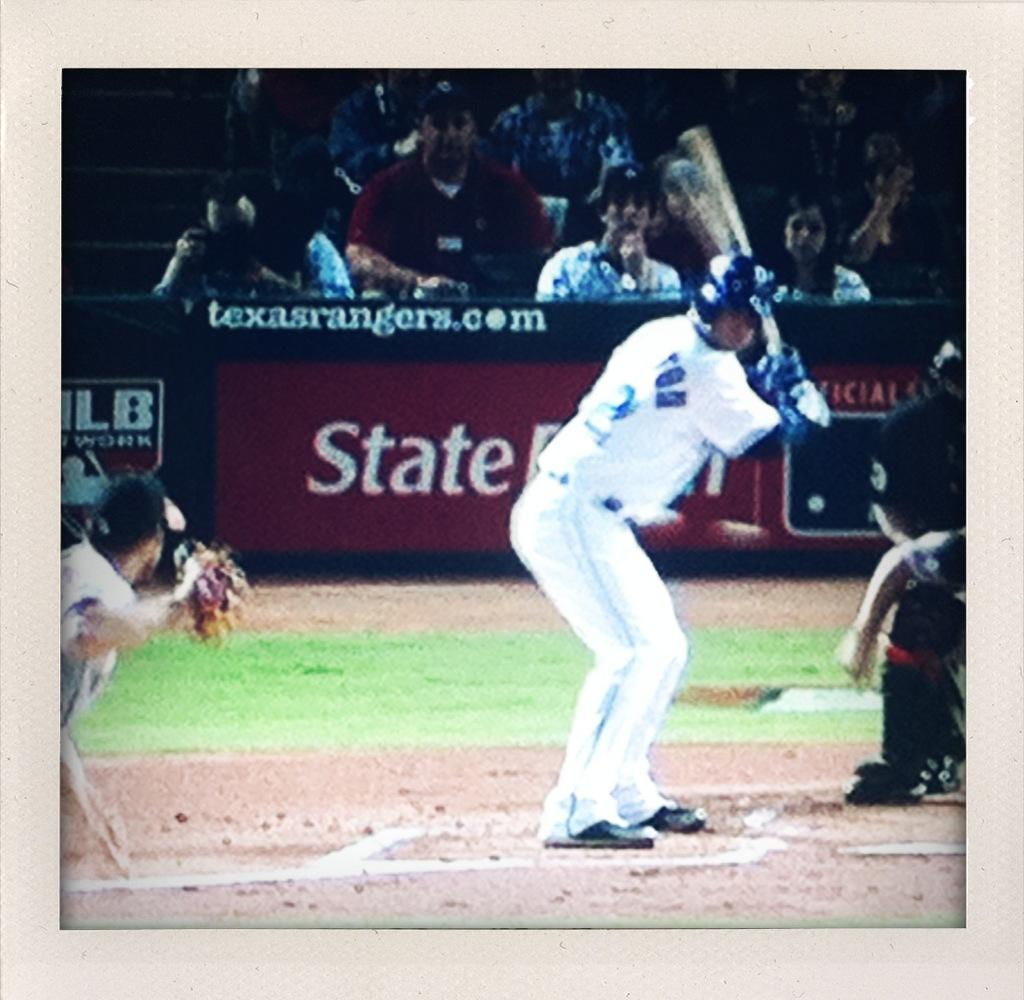Provide a one-sentence caption for the provided image. A man preparing to hit a baseball with a State Farm ad behind him. 